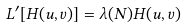Convert formula to latex. <formula><loc_0><loc_0><loc_500><loc_500>L ^ { \prime } [ H ( u , v ) ] = \lambda ( N ) H ( u , v )</formula> 